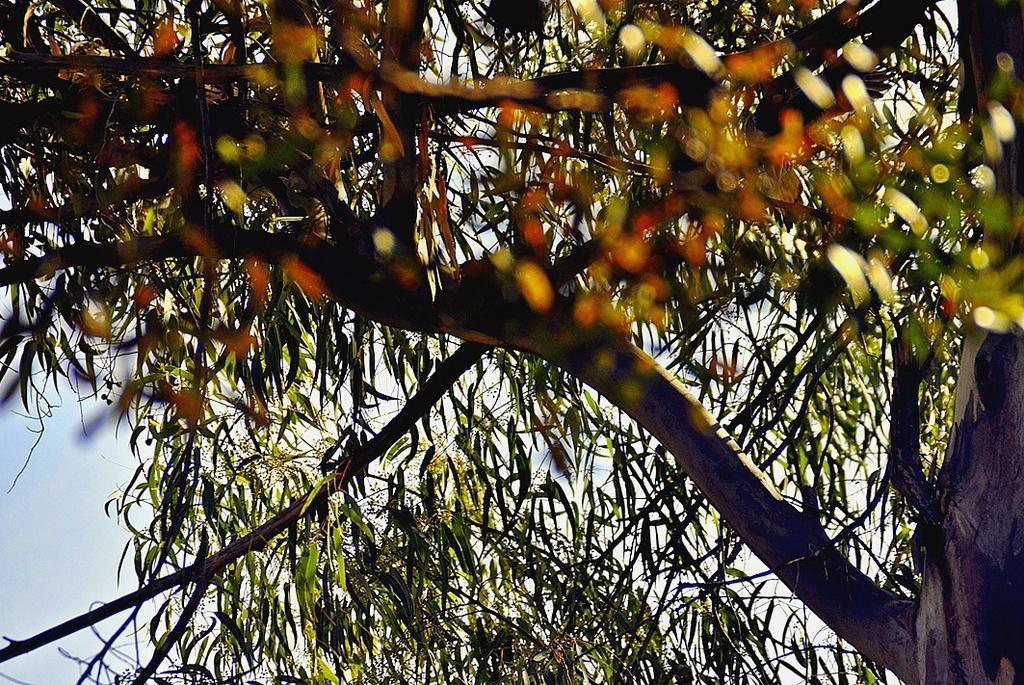What type of vegetation can be seen in the image? There are trees in the image. What colors are present on the trees? The trees have green, black, and orange colors. What is visible in the background of the image? The sky is visible in the background of the image. How much money is being exchanged between the trees in the image? There is no money being exchanged between the trees in the image, as trees are not capable of exchanging money. 